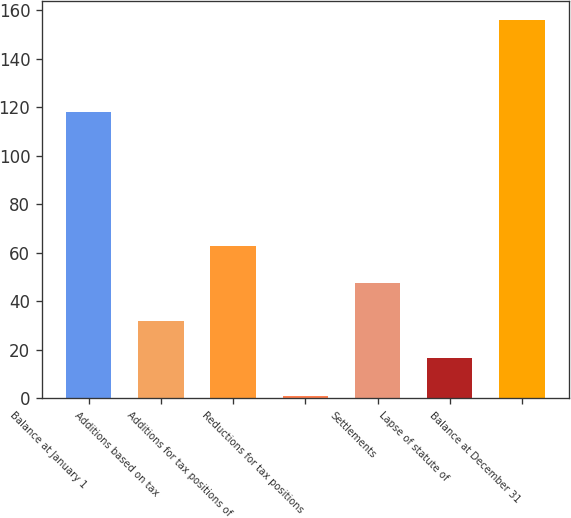Convert chart to OTSL. <chart><loc_0><loc_0><loc_500><loc_500><bar_chart><fcel>Balance at January 1<fcel>Additions based on tax<fcel>Additions for tax positions of<fcel>Reductions for tax positions<fcel>Settlements<fcel>Lapse of statute of<fcel>Balance at December 31<nl><fcel>118<fcel>32<fcel>63<fcel>1<fcel>47.5<fcel>16.5<fcel>156<nl></chart> 